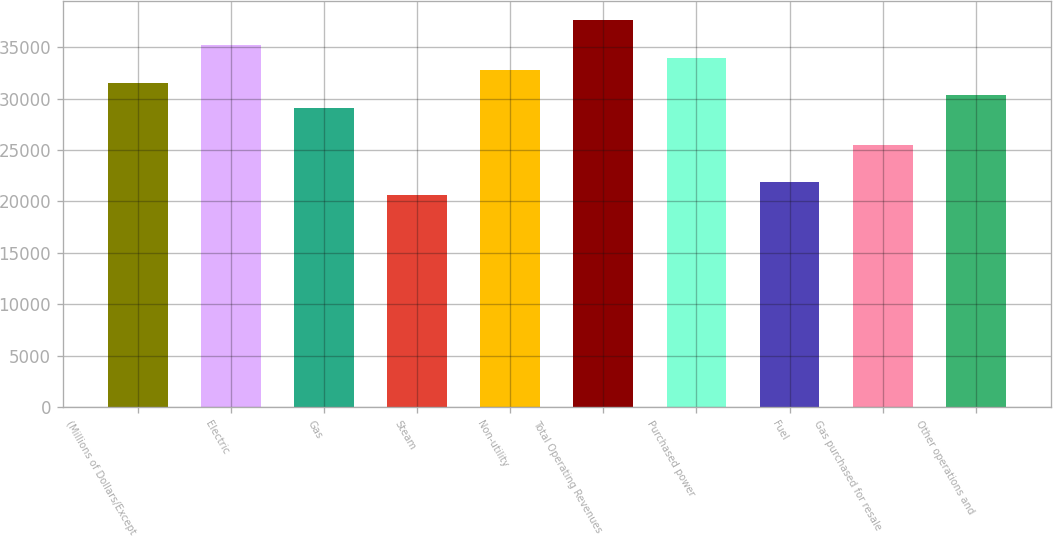Convert chart to OTSL. <chart><loc_0><loc_0><loc_500><loc_500><bar_chart><fcel>(Millions of Dollars/Except<fcel>Electric<fcel>Gas<fcel>Steam<fcel>Non-utility<fcel>Total Operating Revenues<fcel>Purchased power<fcel>Fuel<fcel>Gas purchased for resale<fcel>Other operations and<nl><fcel>31554.6<fcel>35195.4<fcel>29127.4<fcel>20632.2<fcel>32768.2<fcel>37622.6<fcel>33981.8<fcel>21845.8<fcel>25486.6<fcel>30341<nl></chart> 